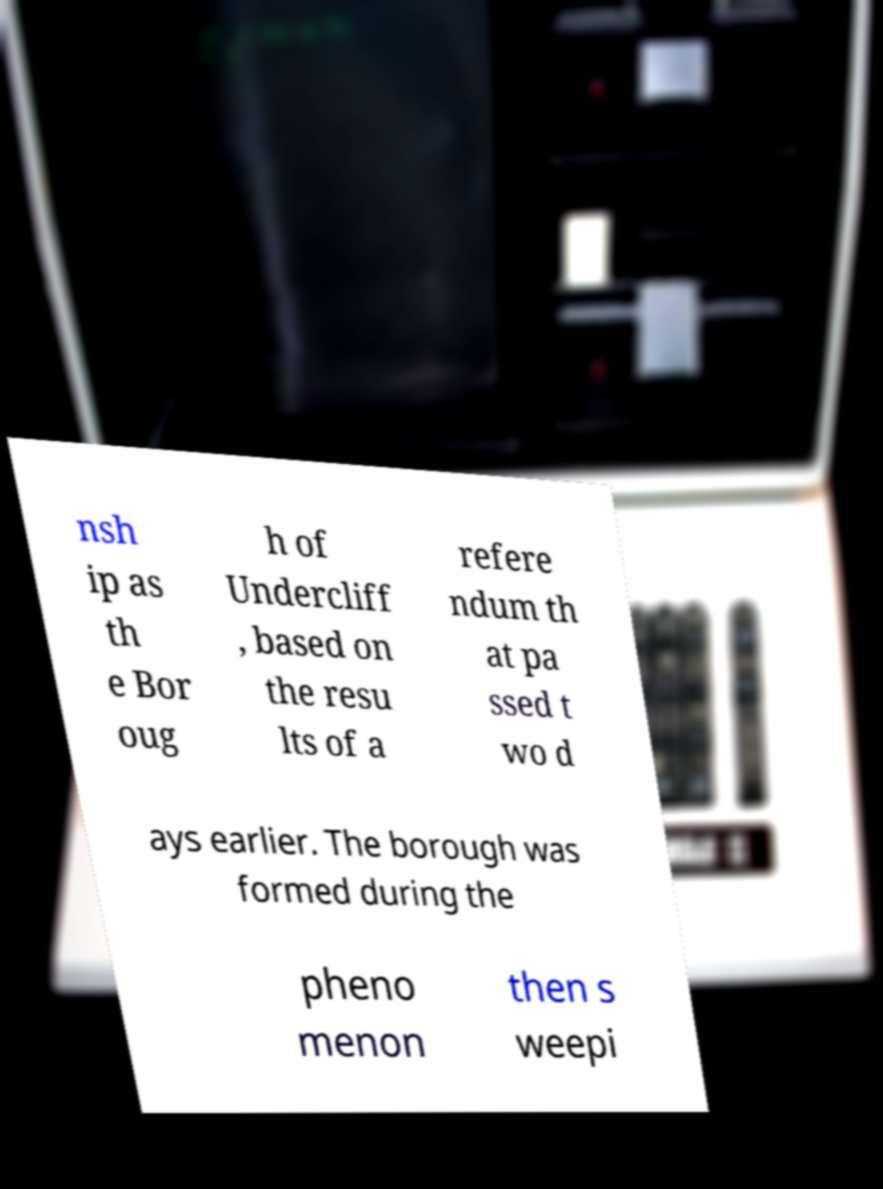There's text embedded in this image that I need extracted. Can you transcribe it verbatim? nsh ip as th e Bor oug h of Undercliff , based on the resu lts of a refere ndum th at pa ssed t wo d ays earlier. The borough was formed during the pheno menon then s weepi 